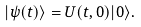<formula> <loc_0><loc_0><loc_500><loc_500>| \psi ( t ) \rangle = U ( t , 0 ) | 0 \rangle .</formula> 